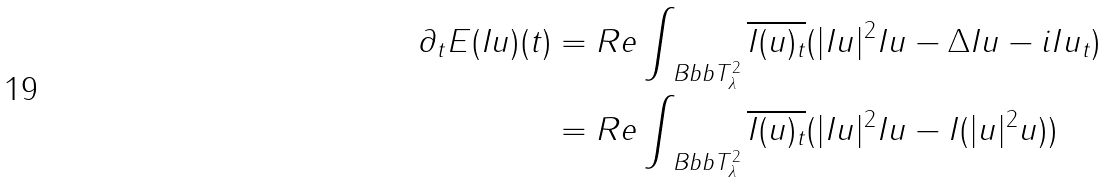Convert formula to latex. <formula><loc_0><loc_0><loc_500><loc_500>\partial _ { t } E ( I u ) ( t ) & = R e \int _ { \ B b b T _ { \lambda } ^ { 2 } } { \overline { I ( u ) _ { t } } ( | I u | ^ { 2 } I u - \Delta I u - i I u _ { t } ) } \\ & = R e \int _ { \ B b b T _ { \lambda } ^ { 2 } } { \overline { I ( u ) _ { t } } ( | I u | ^ { 2 } I u - I ( | u | ^ { 2 } u ) ) }</formula> 